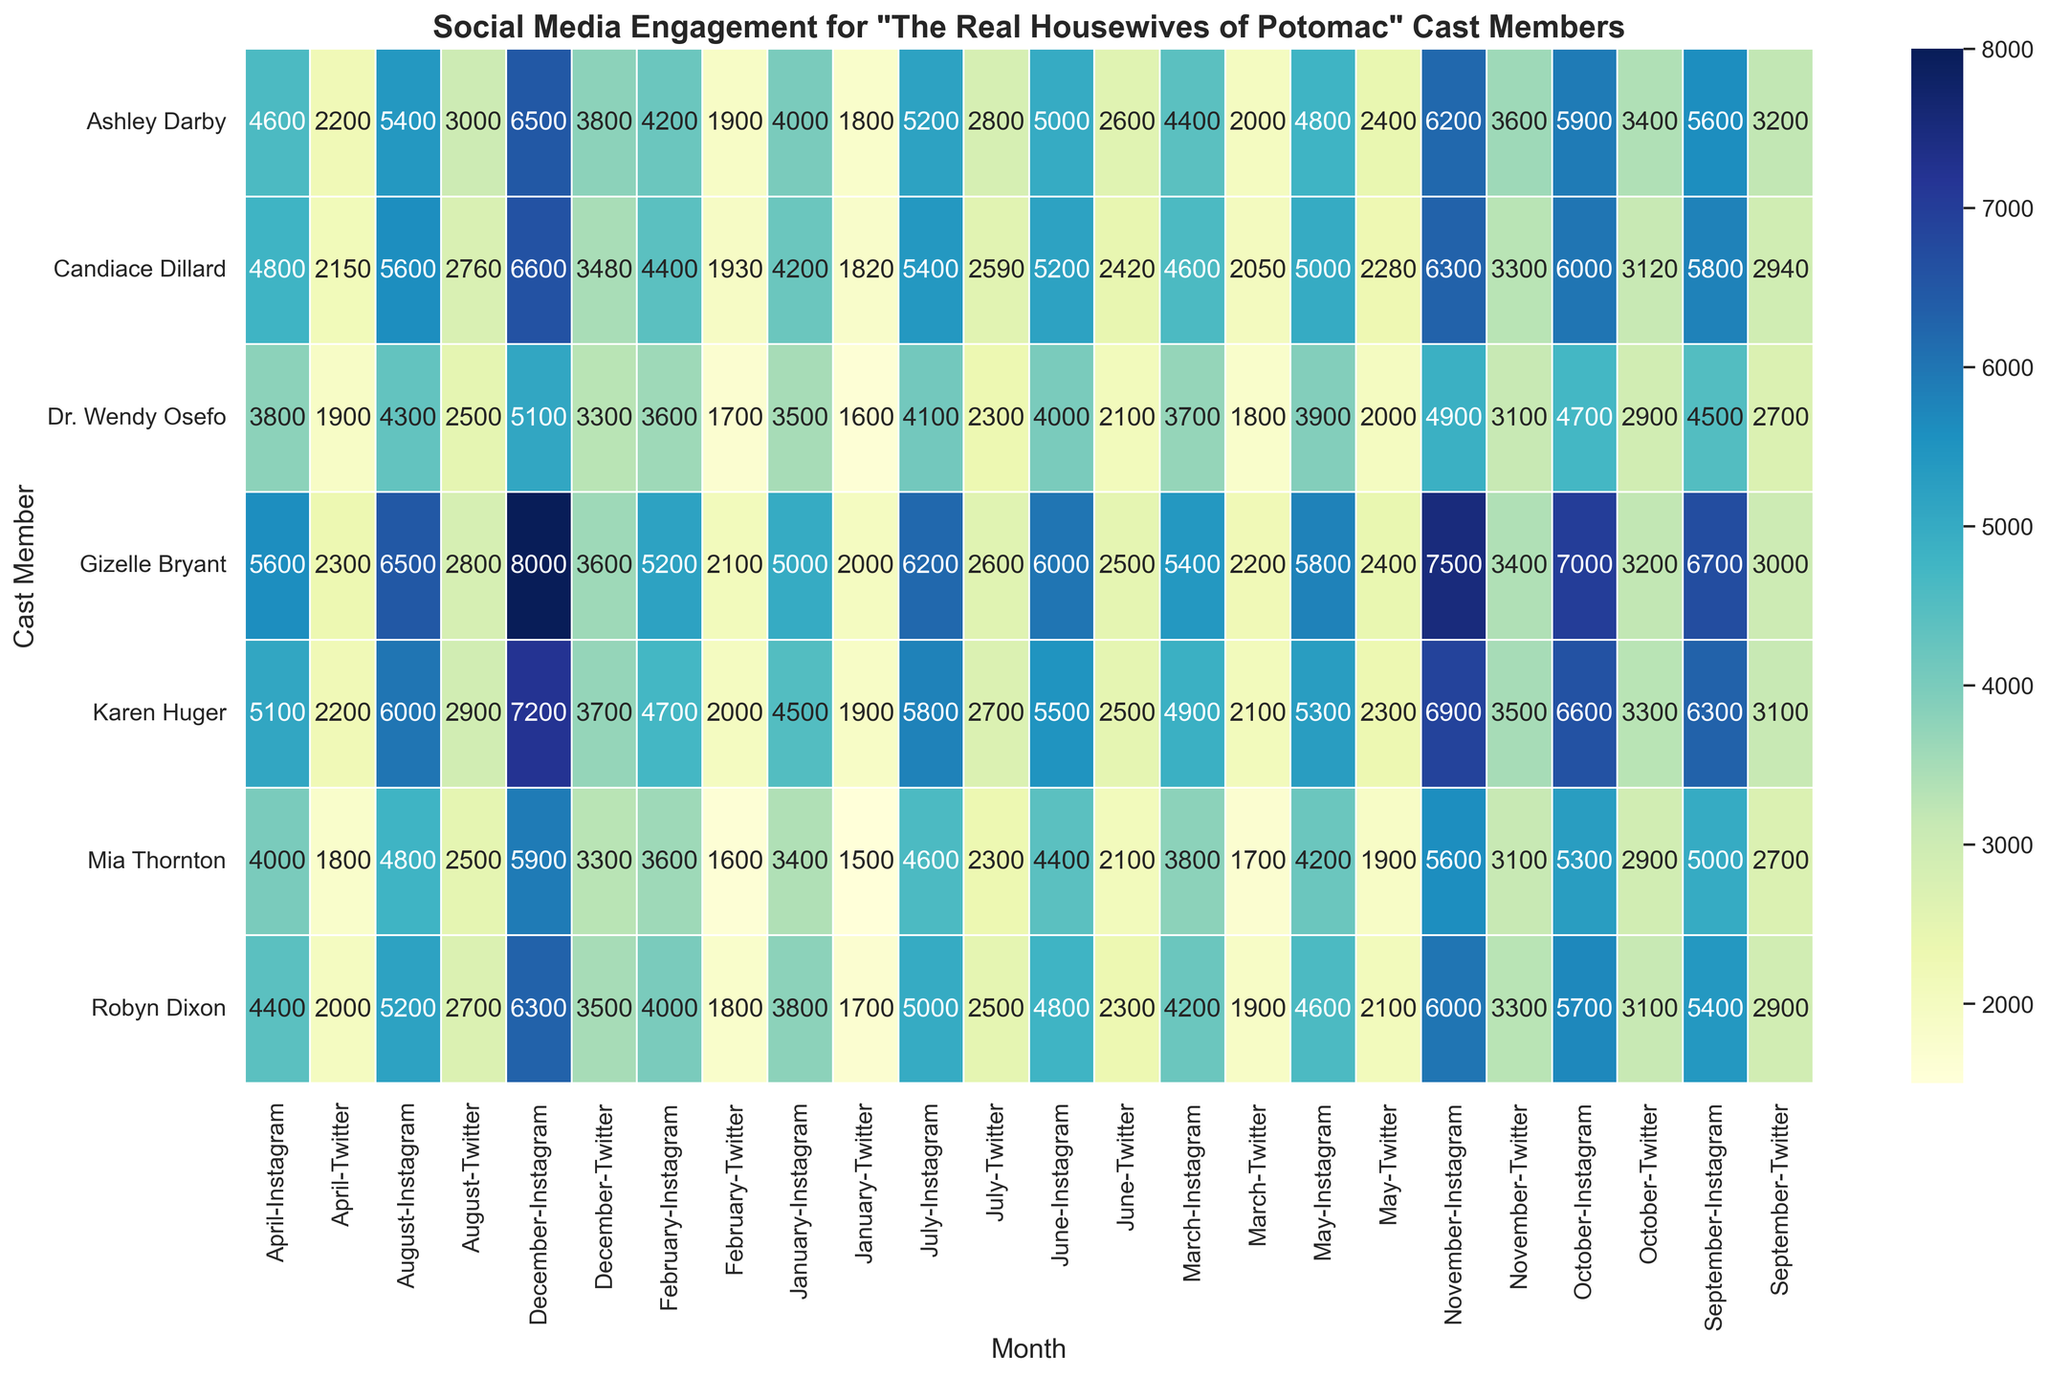Which cast member had the highest Instagram engagement in December? By looking at the heatmap, find the highest value in the column for December under Instagram and identify the corresponding cast member.
Answer: Gizelle Bryant How does Gizelle Bryant's Instagram engagement compare to her Twitter engagement in July? Locate the values for both Instagram and Twitter for Gizelle Bryant in the month of July and compare the two.
Answer: Instagram is higher What is the average engagement growth on Twitter for Ashley Darby from January to June? Find the values for Ashley Darby on Twitter from January to June, and calculate the average growth by summing the monthly values and then dividing by 6. Steps: 
1. Sum of values from January to June: 1800 + 1900 + 2000 + 2200 + 2400 + 2600 = 12900 
2. Divide by the number of months: 12900 / 6 = 2150
Answer: 2150 Which platform had the smallest engagement increase for Robyn Dixon from January to December, and what is the increase? Compute the difference in engagement from January to December for both Instagram and Twitter for Robyn Dixon, then identify the smaller of the two. Steps:
1. Instagram increase: 6300 - 3800 = 2500 
2. Twitter increase: 3500 - 1700 = 1800 
3. Compare the two values to find the smallest increase.
Answer: Twitter, 1800 Which month shows the highest engagement for Candiace Dillard on Instagram? Look at the Candiace Dillard row under Instagram and find the highest value along with its corresponding month.
Answer: December Compare Karen Huger’s Twitter engagement in February to her Instagram engagement in February. Which is higher? Find the values for both platforms for Karen Huger in February and compare them.
Answer: Instagram is higher What is the total engagement for Dr. Wendy Osefo on Instagram from January to December? Sum all the monthly values for Dr. Wendy Osefo on Instagram from January to December. Steps: 
1. Sum of values: 3500 + 3600 + 3700 + 3800 + 3900 + 4000 + 4100 + 4300 + 4500 + 4700 + 4900 + 5100 = 52600
Answer: 52600 What is the difference in engagement between Mia Thornton's Instagram and Twitter accounts in November? Find the values for both platforms for Mia Thornton in November and calculate the difference.
Answer: Instagram is higher by 2500 